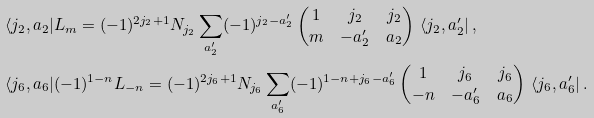Convert formula to latex. <formula><loc_0><loc_0><loc_500><loc_500>& \langle j _ { 2 } , a _ { 2 } | L _ { m } = ( - 1 ) ^ { 2 j _ { 2 } + 1 } N _ { j _ { 2 } } \sum _ { a _ { 2 } ^ { \prime } } ( - 1 ) ^ { j _ { 2 } - a _ { 2 } ^ { \prime } } \begin{pmatrix} 1 & j _ { 2 } & j _ { 2 } \\ m & - a _ { 2 } ^ { \prime } & a _ { 2 } \end{pmatrix} \, \langle j _ { 2 } , a _ { 2 } ^ { \prime } | \, , \\ & \langle j _ { 6 } , a _ { 6 } | ( - 1 ) ^ { 1 - n } L _ { - n } = ( - 1 ) ^ { 2 j _ { 6 } + 1 } N _ { j _ { 6 } } \sum _ { a _ { 6 } ^ { \prime } } ( - 1 ) ^ { 1 - n + j _ { 6 } - a _ { 6 } ^ { \prime } } \begin{pmatrix} 1 & j _ { 6 } & j _ { 6 } \\ - n & - a _ { 6 } ^ { \prime } & a _ { 6 } \end{pmatrix} \, \langle j _ { 6 } , a _ { 6 } ^ { \prime } | \, .</formula> 